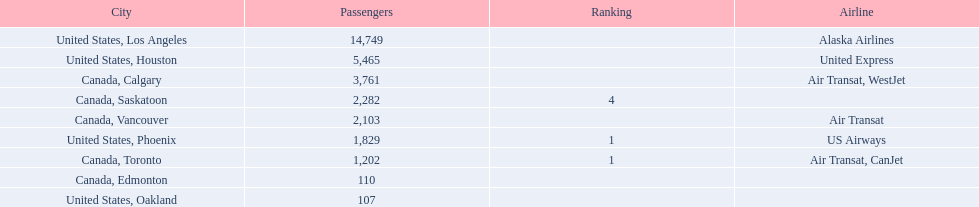Which canadian city had the most passengers traveling from manzanillo international airport in 2013? Calgary. 